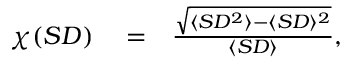<formula> <loc_0><loc_0><loc_500><loc_500>\begin{array} { r l r } { \chi ( S D ) } & = } & { \frac { \sqrt { \langle S D ^ { 2 } \rangle - \langle S D \rangle ^ { 2 } } } { \langle S D \rangle } , } \end{array}</formula> 